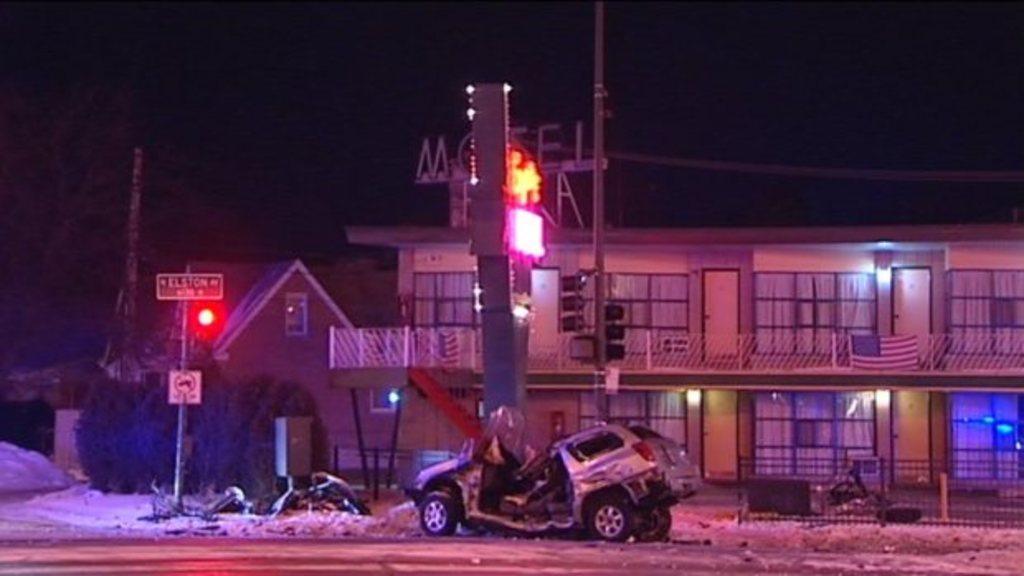Can you describe this image briefly? In this image we can see a car which is crashed there is road, signal and in the background of the image there are some houses, plants and dark sky. 